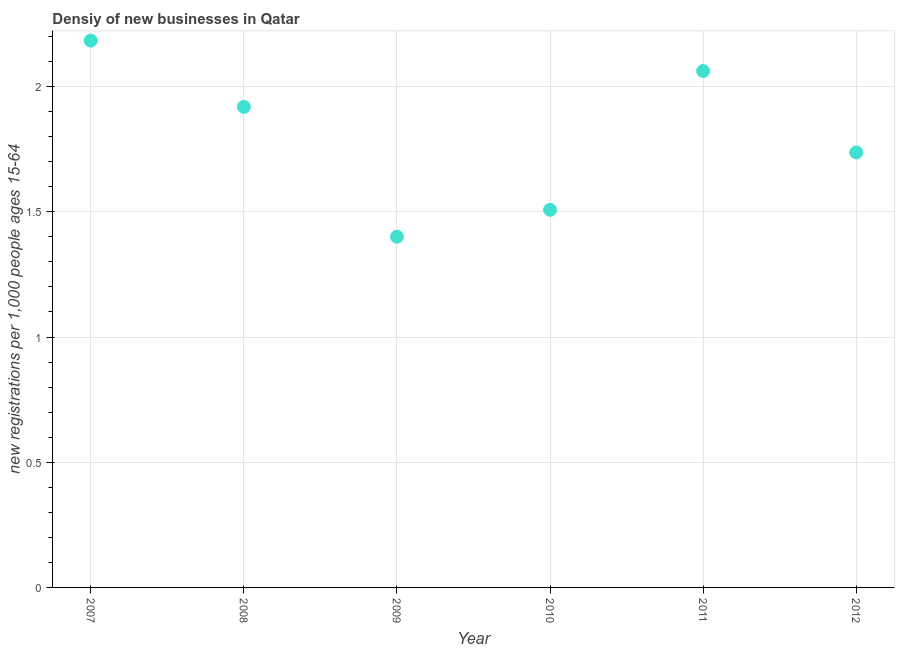What is the density of new business in 2008?
Provide a short and direct response. 1.92. Across all years, what is the maximum density of new business?
Offer a terse response. 2.18. Across all years, what is the minimum density of new business?
Make the answer very short. 1.4. What is the sum of the density of new business?
Give a very brief answer. 10.81. What is the difference between the density of new business in 2008 and 2012?
Offer a very short reply. 0.18. What is the average density of new business per year?
Ensure brevity in your answer.  1.8. What is the median density of new business?
Keep it short and to the point. 1.83. What is the ratio of the density of new business in 2009 to that in 2011?
Offer a terse response. 0.68. Is the density of new business in 2011 less than that in 2012?
Offer a very short reply. No. Is the difference between the density of new business in 2007 and 2008 greater than the difference between any two years?
Your response must be concise. No. What is the difference between the highest and the second highest density of new business?
Your answer should be compact. 0.12. What is the difference between the highest and the lowest density of new business?
Give a very brief answer. 0.78. In how many years, is the density of new business greater than the average density of new business taken over all years?
Keep it short and to the point. 3. How many years are there in the graph?
Offer a very short reply. 6. Are the values on the major ticks of Y-axis written in scientific E-notation?
Your answer should be very brief. No. Does the graph contain grids?
Offer a terse response. Yes. What is the title of the graph?
Ensure brevity in your answer.  Densiy of new businesses in Qatar. What is the label or title of the Y-axis?
Offer a terse response. New registrations per 1,0 people ages 15-64. What is the new registrations per 1,000 people ages 15-64 in 2007?
Provide a succinct answer. 2.18. What is the new registrations per 1,000 people ages 15-64 in 2008?
Ensure brevity in your answer.  1.92. What is the new registrations per 1,000 people ages 15-64 in 2009?
Give a very brief answer. 1.4. What is the new registrations per 1,000 people ages 15-64 in 2010?
Your response must be concise. 1.51. What is the new registrations per 1,000 people ages 15-64 in 2011?
Offer a terse response. 2.06. What is the new registrations per 1,000 people ages 15-64 in 2012?
Ensure brevity in your answer.  1.74. What is the difference between the new registrations per 1,000 people ages 15-64 in 2007 and 2008?
Your answer should be very brief. 0.26. What is the difference between the new registrations per 1,000 people ages 15-64 in 2007 and 2009?
Ensure brevity in your answer.  0.78. What is the difference between the new registrations per 1,000 people ages 15-64 in 2007 and 2010?
Make the answer very short. 0.68. What is the difference between the new registrations per 1,000 people ages 15-64 in 2007 and 2011?
Provide a short and direct response. 0.12. What is the difference between the new registrations per 1,000 people ages 15-64 in 2007 and 2012?
Make the answer very short. 0.45. What is the difference between the new registrations per 1,000 people ages 15-64 in 2008 and 2009?
Your answer should be very brief. 0.52. What is the difference between the new registrations per 1,000 people ages 15-64 in 2008 and 2010?
Provide a short and direct response. 0.41. What is the difference between the new registrations per 1,000 people ages 15-64 in 2008 and 2011?
Your answer should be compact. -0.14. What is the difference between the new registrations per 1,000 people ages 15-64 in 2008 and 2012?
Keep it short and to the point. 0.18. What is the difference between the new registrations per 1,000 people ages 15-64 in 2009 and 2010?
Your response must be concise. -0.11. What is the difference between the new registrations per 1,000 people ages 15-64 in 2009 and 2011?
Make the answer very short. -0.66. What is the difference between the new registrations per 1,000 people ages 15-64 in 2009 and 2012?
Give a very brief answer. -0.34. What is the difference between the new registrations per 1,000 people ages 15-64 in 2010 and 2011?
Offer a very short reply. -0.55. What is the difference between the new registrations per 1,000 people ages 15-64 in 2010 and 2012?
Ensure brevity in your answer.  -0.23. What is the difference between the new registrations per 1,000 people ages 15-64 in 2011 and 2012?
Make the answer very short. 0.33. What is the ratio of the new registrations per 1,000 people ages 15-64 in 2007 to that in 2008?
Your answer should be very brief. 1.14. What is the ratio of the new registrations per 1,000 people ages 15-64 in 2007 to that in 2009?
Your answer should be compact. 1.56. What is the ratio of the new registrations per 1,000 people ages 15-64 in 2007 to that in 2010?
Ensure brevity in your answer.  1.45. What is the ratio of the new registrations per 1,000 people ages 15-64 in 2007 to that in 2011?
Your response must be concise. 1.06. What is the ratio of the new registrations per 1,000 people ages 15-64 in 2007 to that in 2012?
Give a very brief answer. 1.26. What is the ratio of the new registrations per 1,000 people ages 15-64 in 2008 to that in 2009?
Make the answer very short. 1.37. What is the ratio of the new registrations per 1,000 people ages 15-64 in 2008 to that in 2010?
Your answer should be compact. 1.27. What is the ratio of the new registrations per 1,000 people ages 15-64 in 2008 to that in 2011?
Provide a short and direct response. 0.93. What is the ratio of the new registrations per 1,000 people ages 15-64 in 2008 to that in 2012?
Provide a short and direct response. 1.1. What is the ratio of the new registrations per 1,000 people ages 15-64 in 2009 to that in 2010?
Provide a succinct answer. 0.93. What is the ratio of the new registrations per 1,000 people ages 15-64 in 2009 to that in 2011?
Your response must be concise. 0.68. What is the ratio of the new registrations per 1,000 people ages 15-64 in 2009 to that in 2012?
Give a very brief answer. 0.81. What is the ratio of the new registrations per 1,000 people ages 15-64 in 2010 to that in 2011?
Your answer should be very brief. 0.73. What is the ratio of the new registrations per 1,000 people ages 15-64 in 2010 to that in 2012?
Keep it short and to the point. 0.87. What is the ratio of the new registrations per 1,000 people ages 15-64 in 2011 to that in 2012?
Keep it short and to the point. 1.19. 